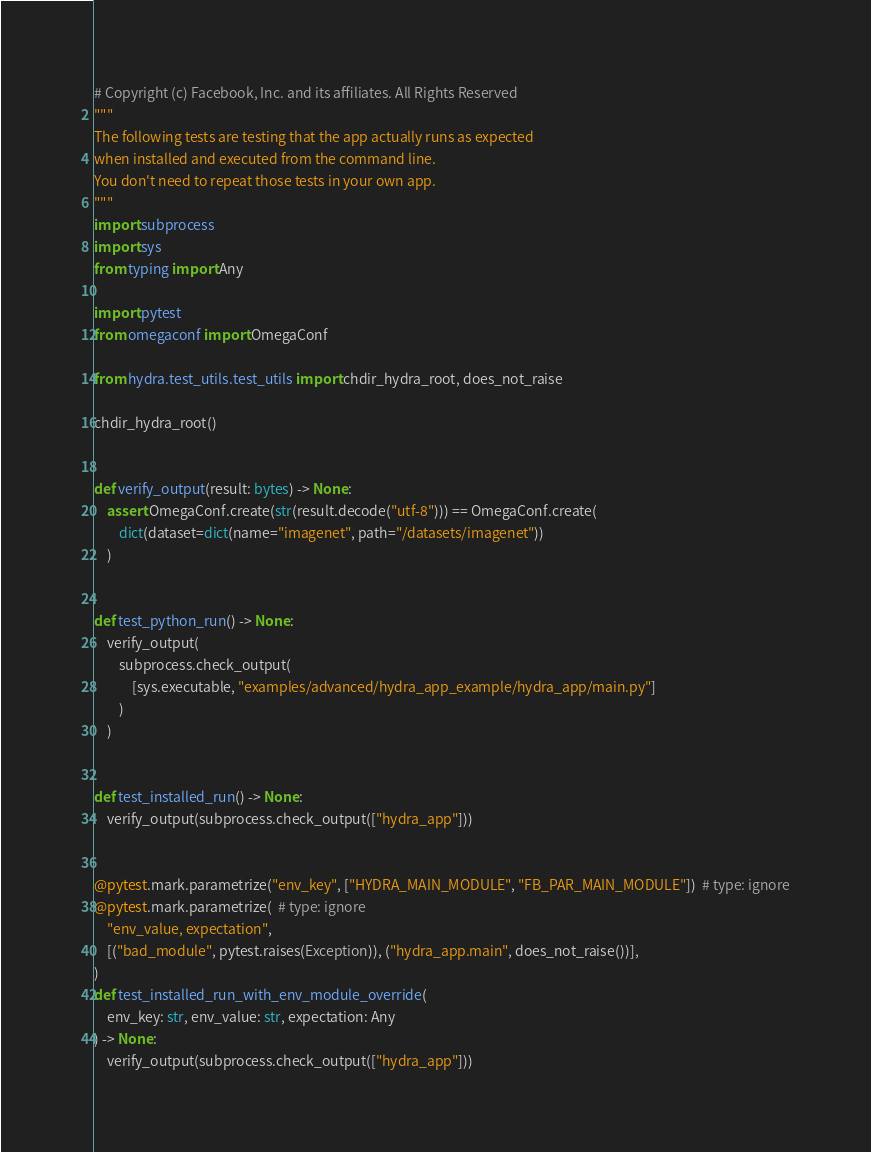Convert code to text. <code><loc_0><loc_0><loc_500><loc_500><_Python_># Copyright (c) Facebook, Inc. and its affiliates. All Rights Reserved
"""
The following tests are testing that the app actually runs as expected
when installed and executed from the command line.
You don't need to repeat those tests in your own app.
"""
import subprocess
import sys
from typing import Any

import pytest
from omegaconf import OmegaConf

from hydra.test_utils.test_utils import chdir_hydra_root, does_not_raise

chdir_hydra_root()


def verify_output(result: bytes) -> None:
    assert OmegaConf.create(str(result.decode("utf-8"))) == OmegaConf.create(
        dict(dataset=dict(name="imagenet", path="/datasets/imagenet"))
    )


def test_python_run() -> None:
    verify_output(
        subprocess.check_output(
            [sys.executable, "examples/advanced/hydra_app_example/hydra_app/main.py"]
        )
    )


def test_installed_run() -> None:
    verify_output(subprocess.check_output(["hydra_app"]))


@pytest.mark.parametrize("env_key", ["HYDRA_MAIN_MODULE", "FB_PAR_MAIN_MODULE"])  # type: ignore
@pytest.mark.parametrize(  # type: ignore
    "env_value, expectation",
    [("bad_module", pytest.raises(Exception)), ("hydra_app.main", does_not_raise())],
)
def test_installed_run_with_env_module_override(
    env_key: str, env_value: str, expectation: Any
) -> None:
    verify_output(subprocess.check_output(["hydra_app"]))
</code> 